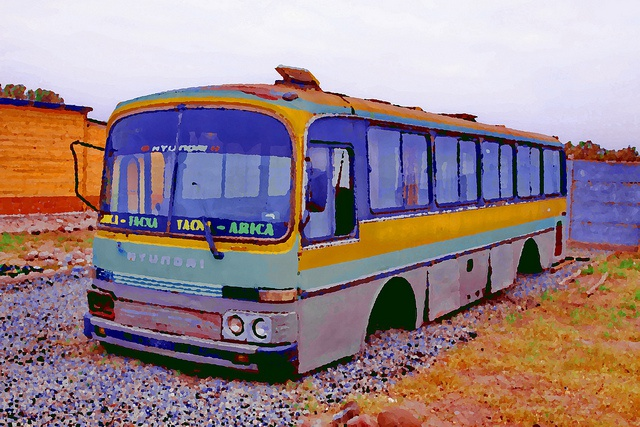Describe the objects in this image and their specific colors. I can see bus in lavender, blue, gray, darkblue, and darkgray tones in this image. 